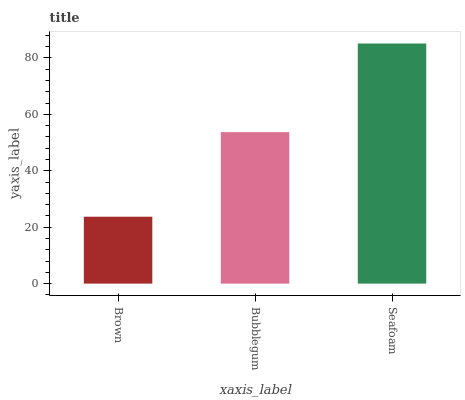Is Brown the minimum?
Answer yes or no. Yes. Is Seafoam the maximum?
Answer yes or no. Yes. Is Bubblegum the minimum?
Answer yes or no. No. Is Bubblegum the maximum?
Answer yes or no. No. Is Bubblegum greater than Brown?
Answer yes or no. Yes. Is Brown less than Bubblegum?
Answer yes or no. Yes. Is Brown greater than Bubblegum?
Answer yes or no. No. Is Bubblegum less than Brown?
Answer yes or no. No. Is Bubblegum the high median?
Answer yes or no. Yes. Is Bubblegum the low median?
Answer yes or no. Yes. Is Brown the high median?
Answer yes or no. No. Is Brown the low median?
Answer yes or no. No. 